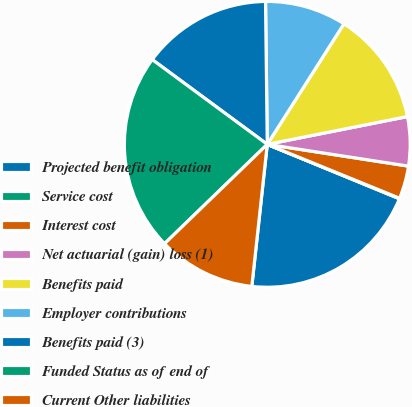Convert chart. <chart><loc_0><loc_0><loc_500><loc_500><pie_chart><fcel>Projected benefit obligation<fcel>Service cost<fcel>Interest cost<fcel>Net actuarial (gain) loss (1)<fcel>Benefits paid<fcel>Employer contributions<fcel>Benefits paid (3)<fcel>Funded Status as of end of<fcel>Current Other liabilities<nl><fcel>20.51%<fcel>0.06%<fcel>3.72%<fcel>5.55%<fcel>12.87%<fcel>9.21%<fcel>14.7%<fcel>22.34%<fcel>11.04%<nl></chart> 